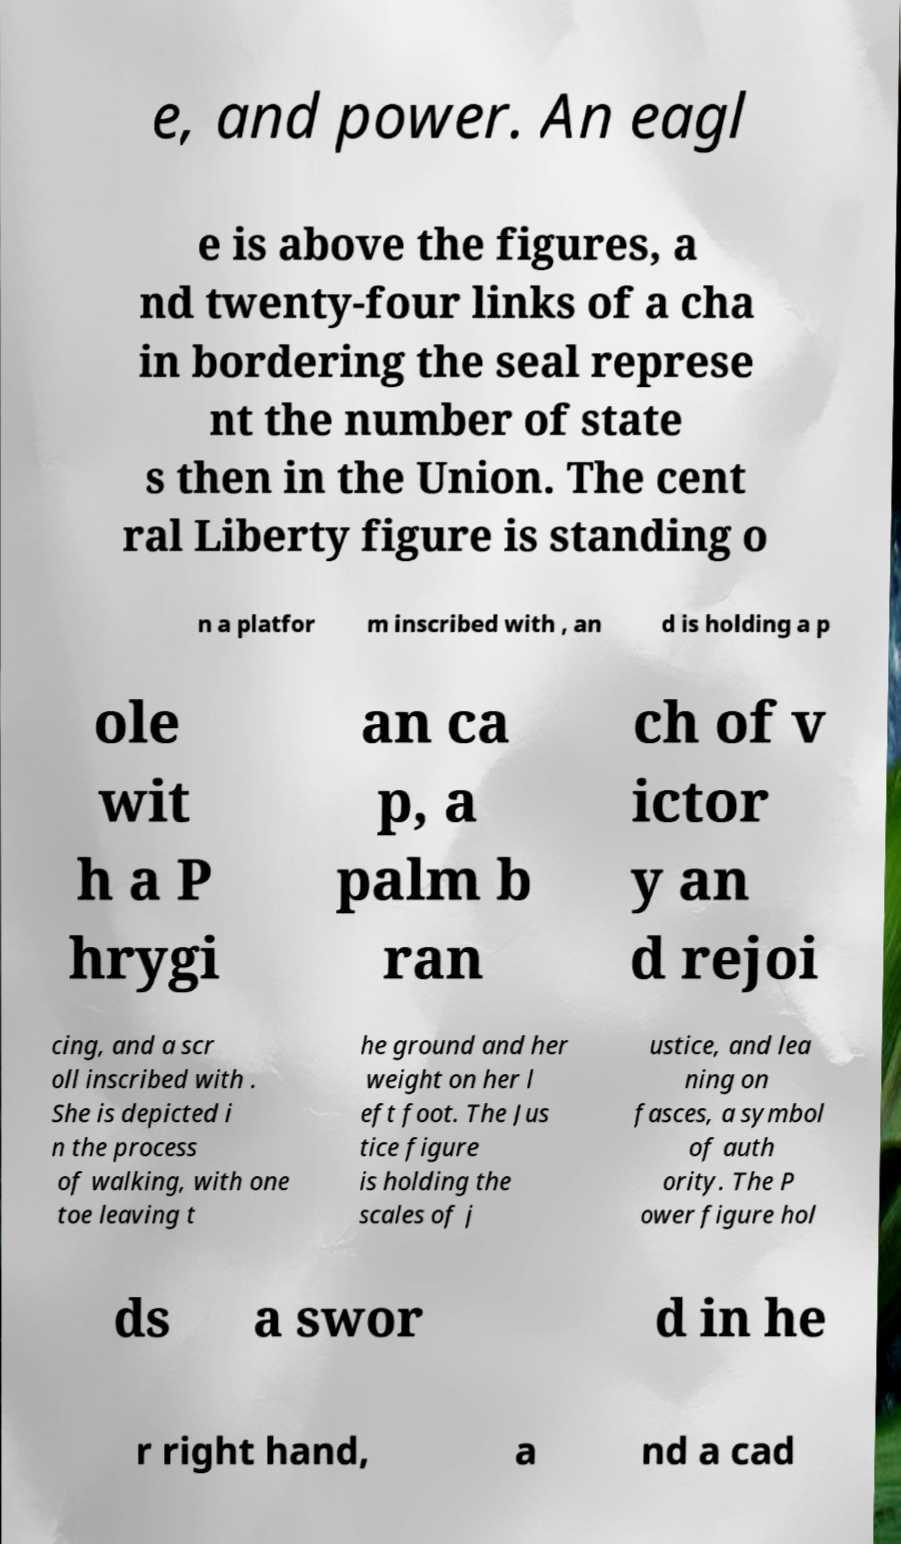Can you accurately transcribe the text from the provided image for me? e, and power. An eagl e is above the figures, a nd twenty-four links of a cha in bordering the seal represe nt the number of state s then in the Union. The cent ral Liberty figure is standing o n a platfor m inscribed with , an d is holding a p ole wit h a P hrygi an ca p, a palm b ran ch of v ictor y an d rejoi cing, and a scr oll inscribed with . She is depicted i n the process of walking, with one toe leaving t he ground and her weight on her l eft foot. The Jus tice figure is holding the scales of j ustice, and lea ning on fasces, a symbol of auth ority. The P ower figure hol ds a swor d in he r right hand, a nd a cad 